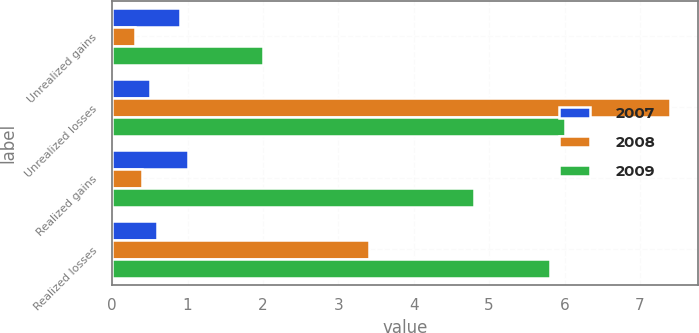Convert chart to OTSL. <chart><loc_0><loc_0><loc_500><loc_500><stacked_bar_chart><ecel><fcel>Unrealized gains<fcel>Unrealized losses<fcel>Realized gains<fcel>Realized losses<nl><fcel>2007<fcel>0.9<fcel>0.5<fcel>1<fcel>0.6<nl><fcel>2008<fcel>0.3<fcel>7.4<fcel>0.4<fcel>3.4<nl><fcel>2009<fcel>2<fcel>6<fcel>4.8<fcel>5.8<nl></chart> 